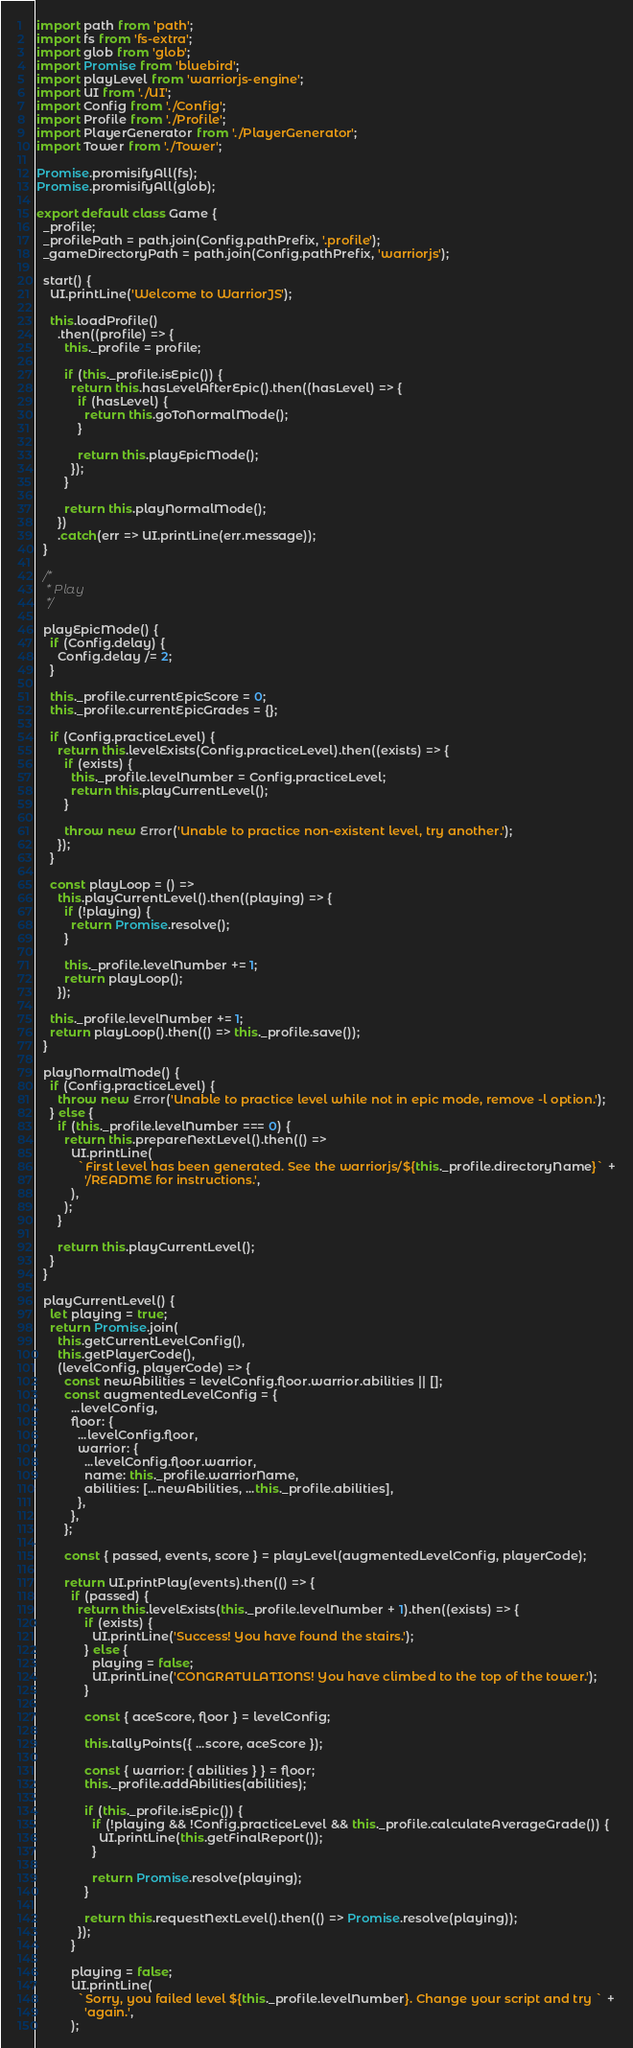Convert code to text. <code><loc_0><loc_0><loc_500><loc_500><_JavaScript_>import path from 'path';
import fs from 'fs-extra';
import glob from 'glob';
import Promise from 'bluebird';
import playLevel from 'warriorjs-engine';
import UI from './UI';
import Config from './Config';
import Profile from './Profile';
import PlayerGenerator from './PlayerGenerator';
import Tower from './Tower';

Promise.promisifyAll(fs);
Promise.promisifyAll(glob);

export default class Game {
  _profile;
  _profilePath = path.join(Config.pathPrefix, '.profile');
  _gameDirectoryPath = path.join(Config.pathPrefix, 'warriorjs');

  start() {
    UI.printLine('Welcome to WarriorJS');

    this.loadProfile()
      .then((profile) => {
        this._profile = profile;

        if (this._profile.isEpic()) {
          return this.hasLevelAfterEpic().then((hasLevel) => {
            if (hasLevel) {
              return this.goToNormalMode();
            }

            return this.playEpicMode();
          });
        }

        return this.playNormalMode();
      })
      .catch(err => UI.printLine(err.message));
  }

  /*
   * Play
   */

  playEpicMode() {
    if (Config.delay) {
      Config.delay /= 2;
    }

    this._profile.currentEpicScore = 0;
    this._profile.currentEpicGrades = {};

    if (Config.practiceLevel) {
      return this.levelExists(Config.practiceLevel).then((exists) => {
        if (exists) {
          this._profile.levelNumber = Config.practiceLevel;
          return this.playCurrentLevel();
        }

        throw new Error('Unable to practice non-existent level, try another.');
      });
    }

    const playLoop = () =>
      this.playCurrentLevel().then((playing) => {
        if (!playing) {
          return Promise.resolve();
        }

        this._profile.levelNumber += 1;
        return playLoop();
      });

    this._profile.levelNumber += 1;
    return playLoop().then(() => this._profile.save());
  }

  playNormalMode() {
    if (Config.practiceLevel) {
      throw new Error('Unable to practice level while not in epic mode, remove -l option.');
    } else {
      if (this._profile.levelNumber === 0) {
        return this.prepareNextLevel().then(() =>
          UI.printLine(
            `First level has been generated. See the warriorjs/${this._profile.directoryName}` +
              '/README for instructions.',
          ),
        );
      }

      return this.playCurrentLevel();
    }
  }

  playCurrentLevel() {
    let playing = true;
    return Promise.join(
      this.getCurrentLevelConfig(),
      this.getPlayerCode(),
      (levelConfig, playerCode) => {
        const newAbilities = levelConfig.floor.warrior.abilities || [];
        const augmentedLevelConfig = {
          ...levelConfig,
          floor: {
            ...levelConfig.floor,
            warrior: {
              ...levelConfig.floor.warrior,
              name: this._profile.warriorName,
              abilities: [...newAbilities, ...this._profile.abilities],
            },
          },
        };

        const { passed, events, score } = playLevel(augmentedLevelConfig, playerCode);

        return UI.printPlay(events).then(() => {
          if (passed) {
            return this.levelExists(this._profile.levelNumber + 1).then((exists) => {
              if (exists) {
                UI.printLine('Success! You have found the stairs.');
              } else {
                playing = false;
                UI.printLine('CONGRATULATIONS! You have climbed to the top of the tower.');
              }

              const { aceScore, floor } = levelConfig;

              this.tallyPoints({ ...score, aceScore });

              const { warrior: { abilities } } = floor;
              this._profile.addAbilities(abilities);

              if (this._profile.isEpic()) {
                if (!playing && !Config.practiceLevel && this._profile.calculateAverageGrade()) {
                  UI.printLine(this.getFinalReport());
                }

                return Promise.resolve(playing);
              }

              return this.requestNextLevel().then(() => Promise.resolve(playing));
            });
          }

          playing = false;
          UI.printLine(
            `Sorry, you failed level ${this._profile.levelNumber}. Change your script and try ` +
              'again.',
          );</code> 